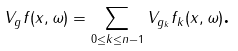Convert formula to latex. <formula><loc_0><loc_0><loc_500><loc_500>V _ { g } f ( x , \omega ) = \sum _ { 0 \leq k \leq n - 1 } V _ { g _ { k } } f _ { k } ( x , \omega ) \text {.}</formula> 